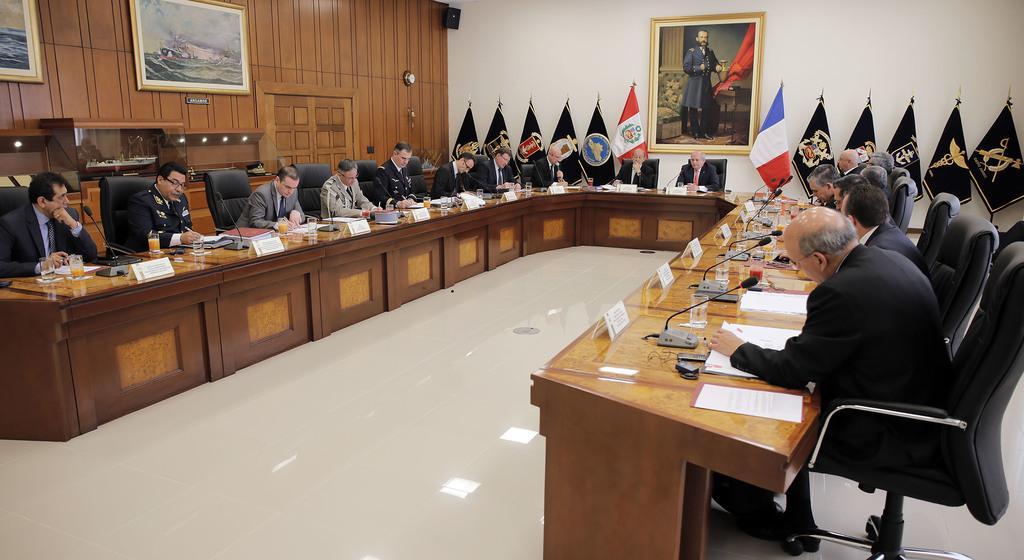How would you summarize this image in a sentence or two? This is a picture taken in a room, there are a group of people sitting on chairs in front of these people there is a table on the table there are papers, glasses, microphone and name board. Behind the people there is a wooden wall with photo frames, and flags and a wall with photo. 